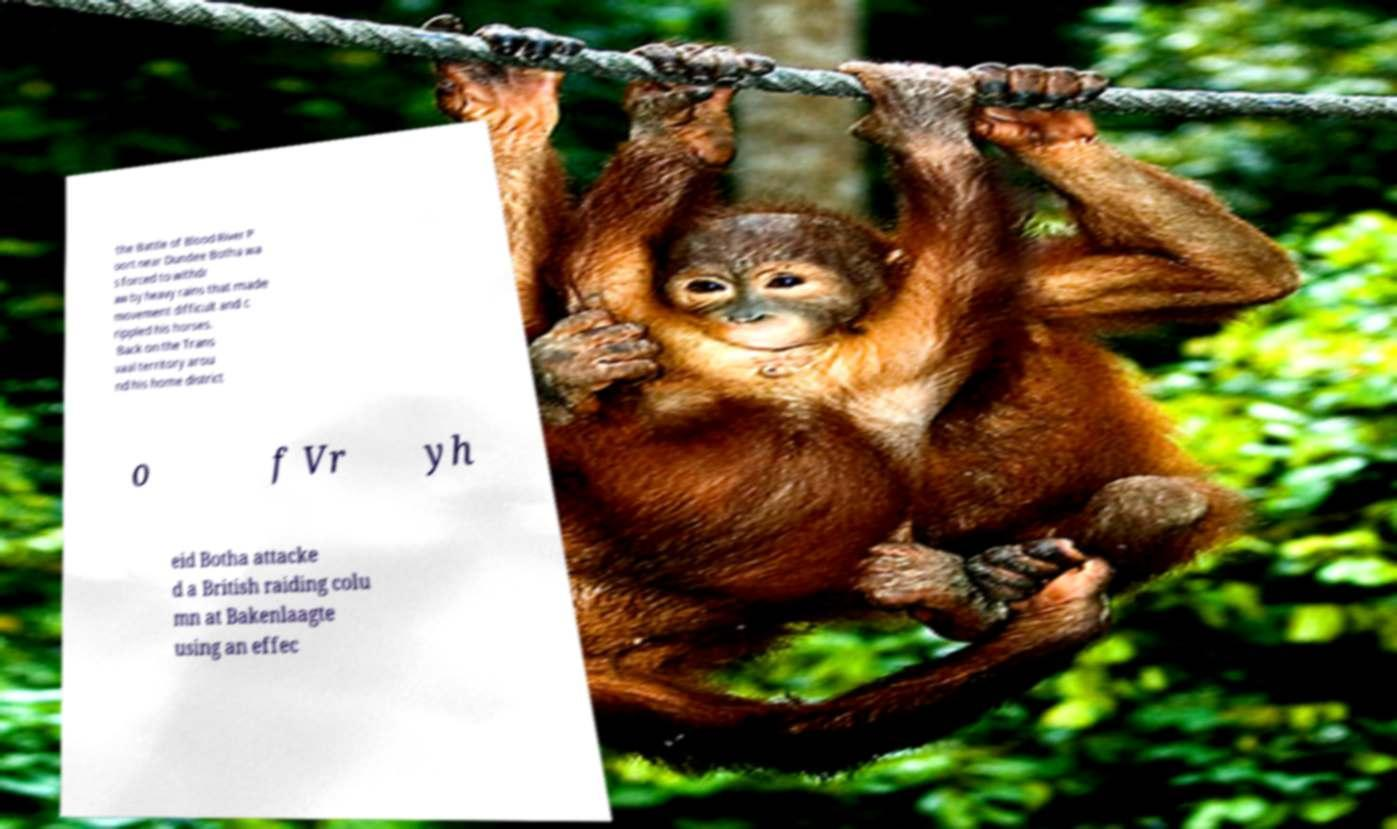For documentation purposes, I need the text within this image transcribed. Could you provide that? the Battle of Blood River P oort near Dundee Botha wa s forced to withdr aw by heavy rains that made movement difficult and c rippled his horses. Back on the Trans vaal territory arou nd his home district o f Vr yh eid Botha attacke d a British raiding colu mn at Bakenlaagte using an effec 